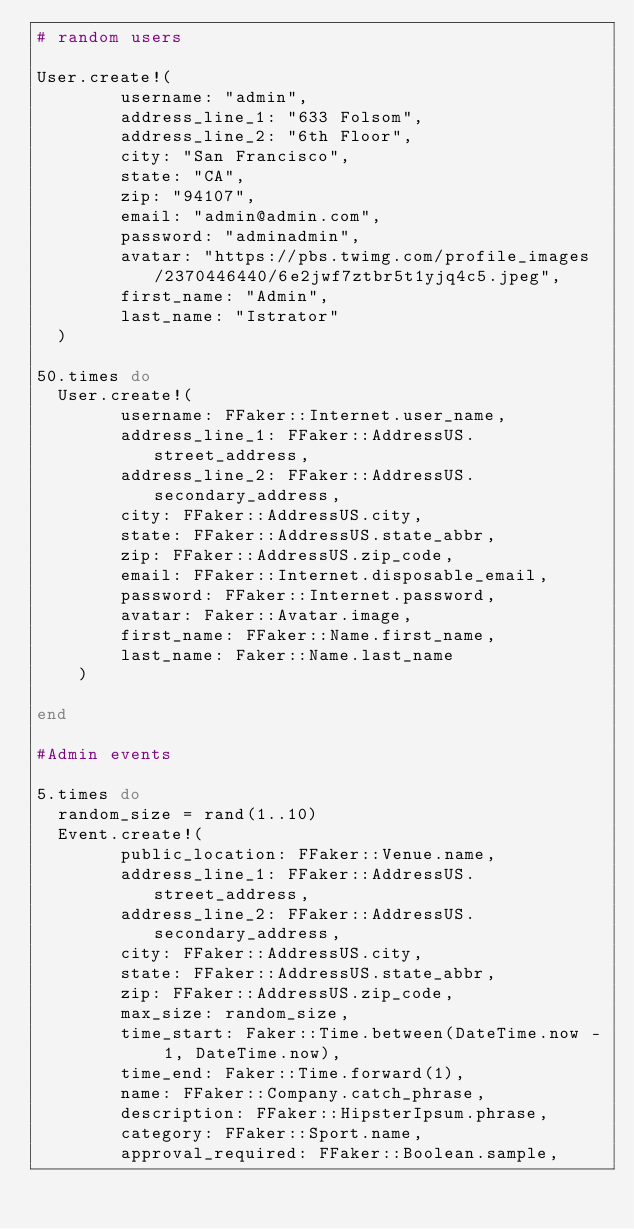Convert code to text. <code><loc_0><loc_0><loc_500><loc_500><_Ruby_># random users

User.create!(
        username: "admin",
        address_line_1: "633 Folsom",
        address_line_2: "6th Floor",
        city: "San Francisco",
        state: "CA",
        zip: "94107",
        email: "admin@admin.com",
        password: "adminadmin",
        avatar: "https://pbs.twimg.com/profile_images/2370446440/6e2jwf7ztbr5t1yjq4c5.jpeg",
        first_name: "Admin",
        last_name: "Istrator"
  )

50.times do
  User.create!(
        username: FFaker::Internet.user_name,
        address_line_1: FFaker::AddressUS.street_address,
        address_line_2: FFaker::AddressUS.secondary_address,
        city: FFaker::AddressUS.city,
        state: FFaker::AddressUS.state_abbr,
        zip: FFaker::AddressUS.zip_code,
        email: FFaker::Internet.disposable_email,
        password: FFaker::Internet.password,
        avatar: Faker::Avatar.image,
        first_name: FFaker::Name.first_name,
        last_name: Faker::Name.last_name
    )

end

#Admin events

5.times do
  random_size = rand(1..10)
  Event.create!(
        public_location: FFaker::Venue.name,
        address_line_1: FFaker::AddressUS.street_address,
        address_line_2: FFaker::AddressUS.secondary_address,
        city: FFaker::AddressUS.city,
        state: FFaker::AddressUS.state_abbr,
        zip: FFaker::AddressUS.zip_code,
        max_size: random_size,
        time_start: Faker::Time.between(DateTime.now - 1, DateTime.now),
        time_end: Faker::Time.forward(1),
        name: FFaker::Company.catch_phrase,
        description: FFaker::HipsterIpsum.phrase,
        category: FFaker::Sport.name,
        approval_required: FFaker::Boolean.sample,</code> 